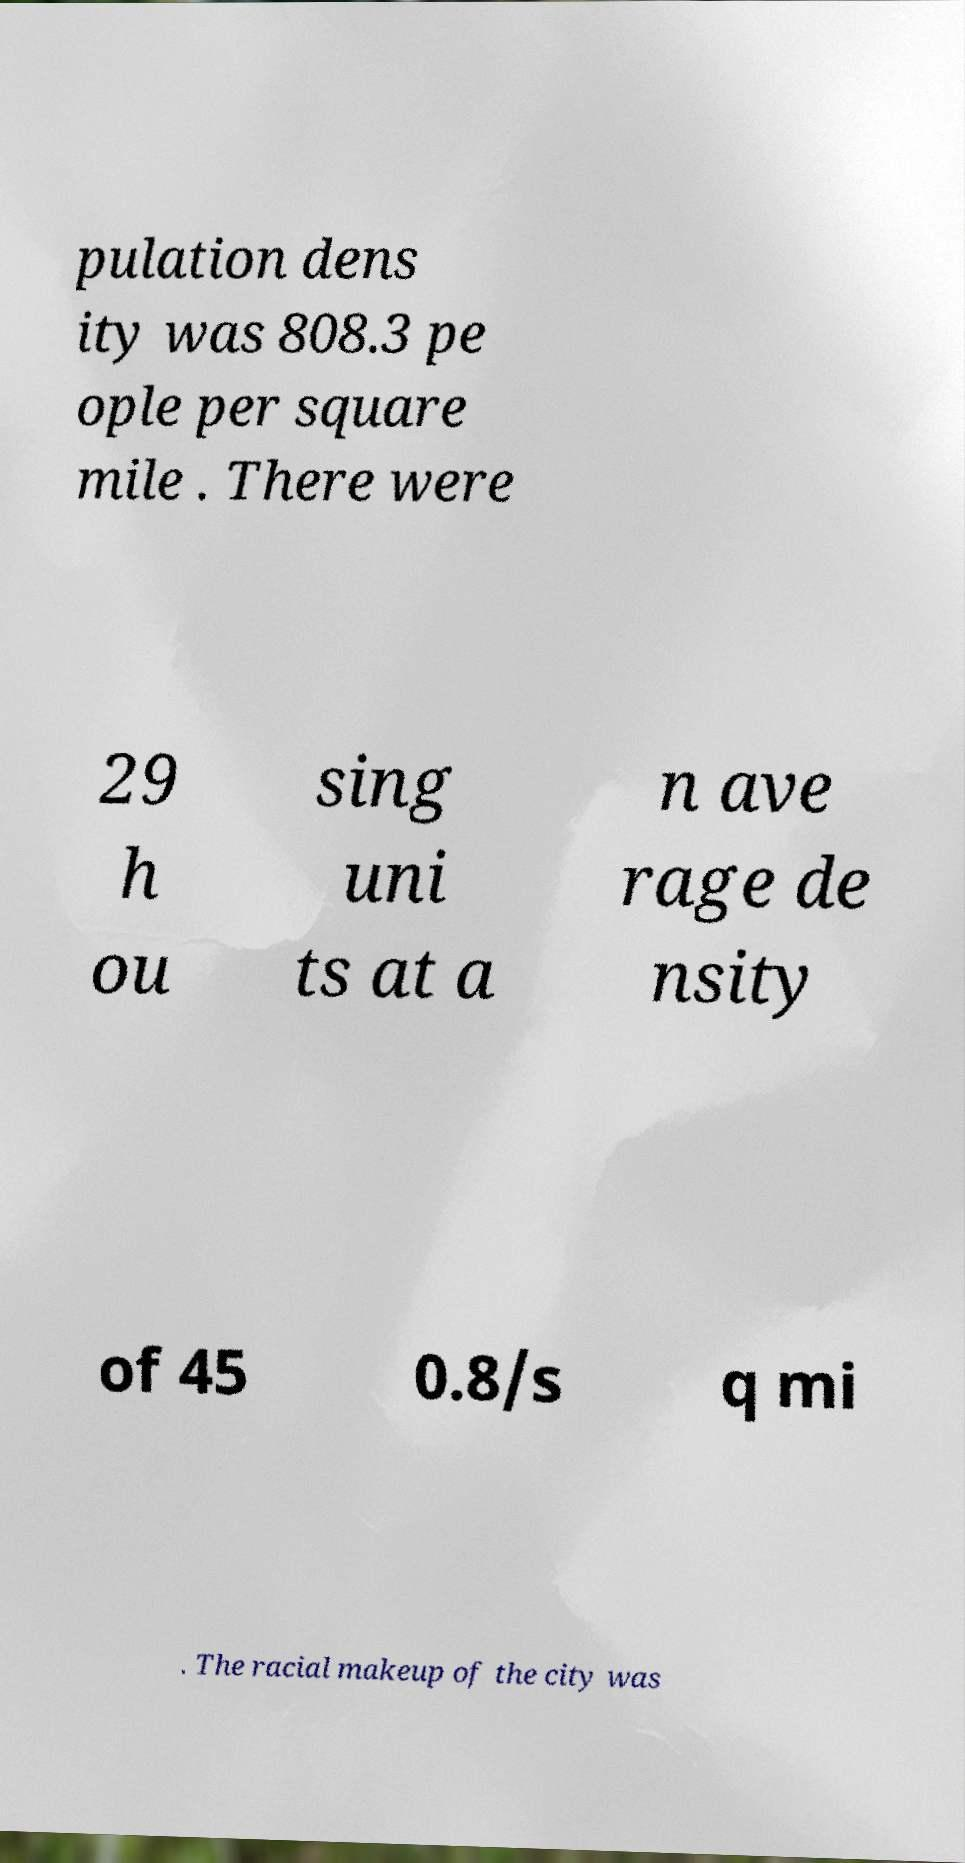Can you accurately transcribe the text from the provided image for me? pulation dens ity was 808.3 pe ople per square mile . There were 29 h ou sing uni ts at a n ave rage de nsity of 45 0.8/s q mi . The racial makeup of the city was 